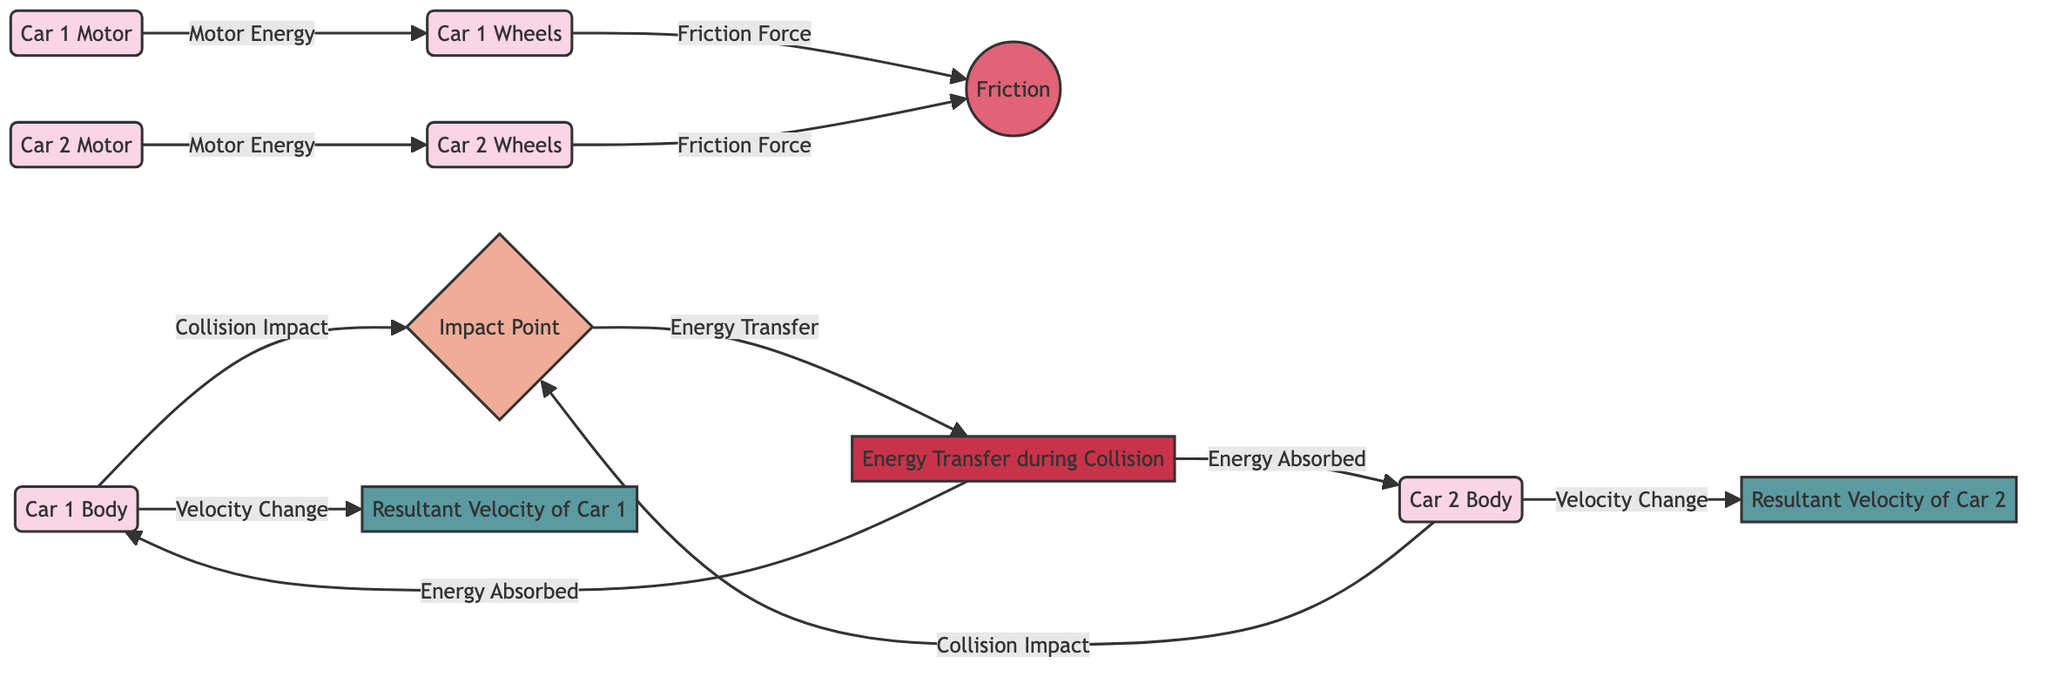What are the components of Car 1 shown in the diagram? The nodes representing Car 1 are the body, wheels, and motor, which can be identified through their specific labels in the network.
Answer: Car 1 Body, Car 1 Wheels, Car 1 Motor How many edges are there in the diagram? By counting the lines connecting the nodes, we can identify that there are multiple connections representing the interactions, energy flows, and changes, which amount to a specific number.
Answer: 12 What type of node is the "Impact Point"? The label of the node is enclosed in braces, indicating it represents an event within the diagram. This can be confirmed by its classification in the network.
Answer: event Which motor powers Car 2’s wheels? Following the energy flow from the Car 2 motor to its corresponding wheels, we identify that the Car 2 Motor drives this component.
Answer: Car 2 Motor What energy does the "Energy Transfer during Collision" node provide to Car 1? By analyzing the arrows emanating from the energy transfer node, we can see that it specifically transfers energy to both Car 1 and Car 2 bodies.
Answer: Energy Absorbed What effect does friction have on the wheels of both cars? The friction is represented as a force acting on both car wheels, showing its impact through arrows indicating energy loss or drag during movement.
Answer: Friction Force Which two nodes are involved in the "Velocity Change" for Car 1? The nodes connected by the arrow labeled "Velocity Change" show the relationship between the Car 1 Body and its resultant velocity node, indicating the physical change in speed.
Answer: Car 1 Body, Resultant Velocity of Car 1 What is the result of the energy transfer at the impact point? Reviewing the flow from the impact point node to the energy transfer node clarifies that it describes the energy transferred during the collision affecting both cars.
Answer: Energy Transfer List the types of nodes present in the diagram. By categorizing each type of node based on their classification, we can summarize all distinct types present in the network.
Answer: component, event, force, energy, velocity 